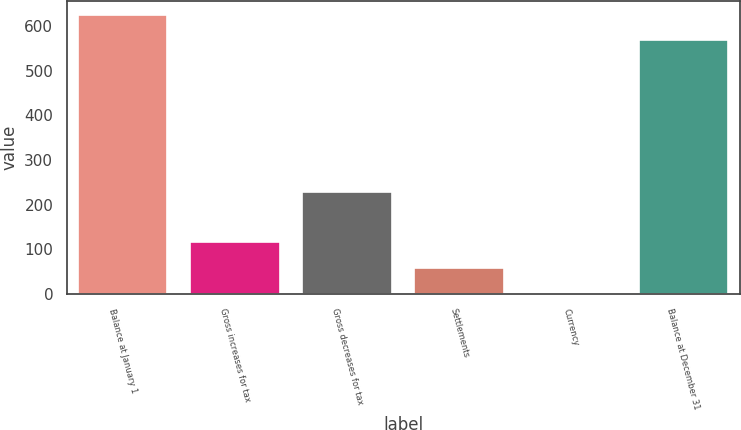Convert chart. <chart><loc_0><loc_0><loc_500><loc_500><bar_chart><fcel>Balance at January 1<fcel>Gross increases for tax<fcel>Gross decreases for tax<fcel>Settlements<fcel>Currency<fcel>Balance at December 31<nl><fcel>624.8<fcel>115.6<fcel>229.2<fcel>58.8<fcel>2<fcel>568<nl></chart> 